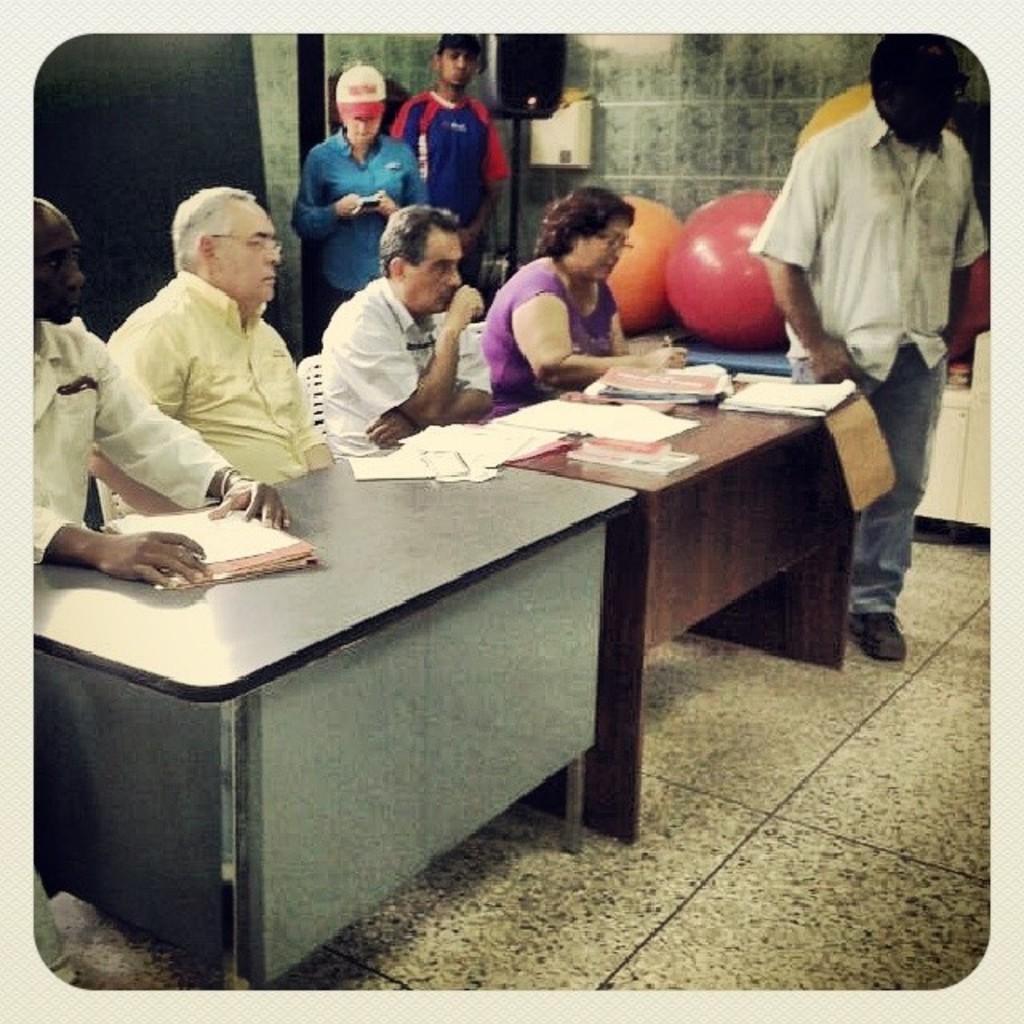Please provide a concise description of this image. In the picture we can see some people are sitting on a chair near the tables, on the table we can see some papers and files on it, and one person standing near to the table, in the background we can see there are also two people standing and wall. 